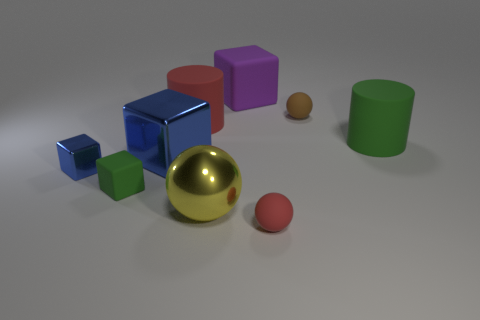Subtract all brown balls. How many balls are left? 2 Subtract all green blocks. How many blocks are left? 3 Add 1 big metallic things. How many objects exist? 10 Subtract all cylinders. How many objects are left? 7 Subtract all red cylinders. How many red spheres are left? 1 Subtract all large objects. Subtract all large yellow metallic balls. How many objects are left? 3 Add 7 red rubber cylinders. How many red rubber cylinders are left? 8 Add 1 metallic objects. How many metallic objects exist? 4 Subtract 0 red blocks. How many objects are left? 9 Subtract 1 balls. How many balls are left? 2 